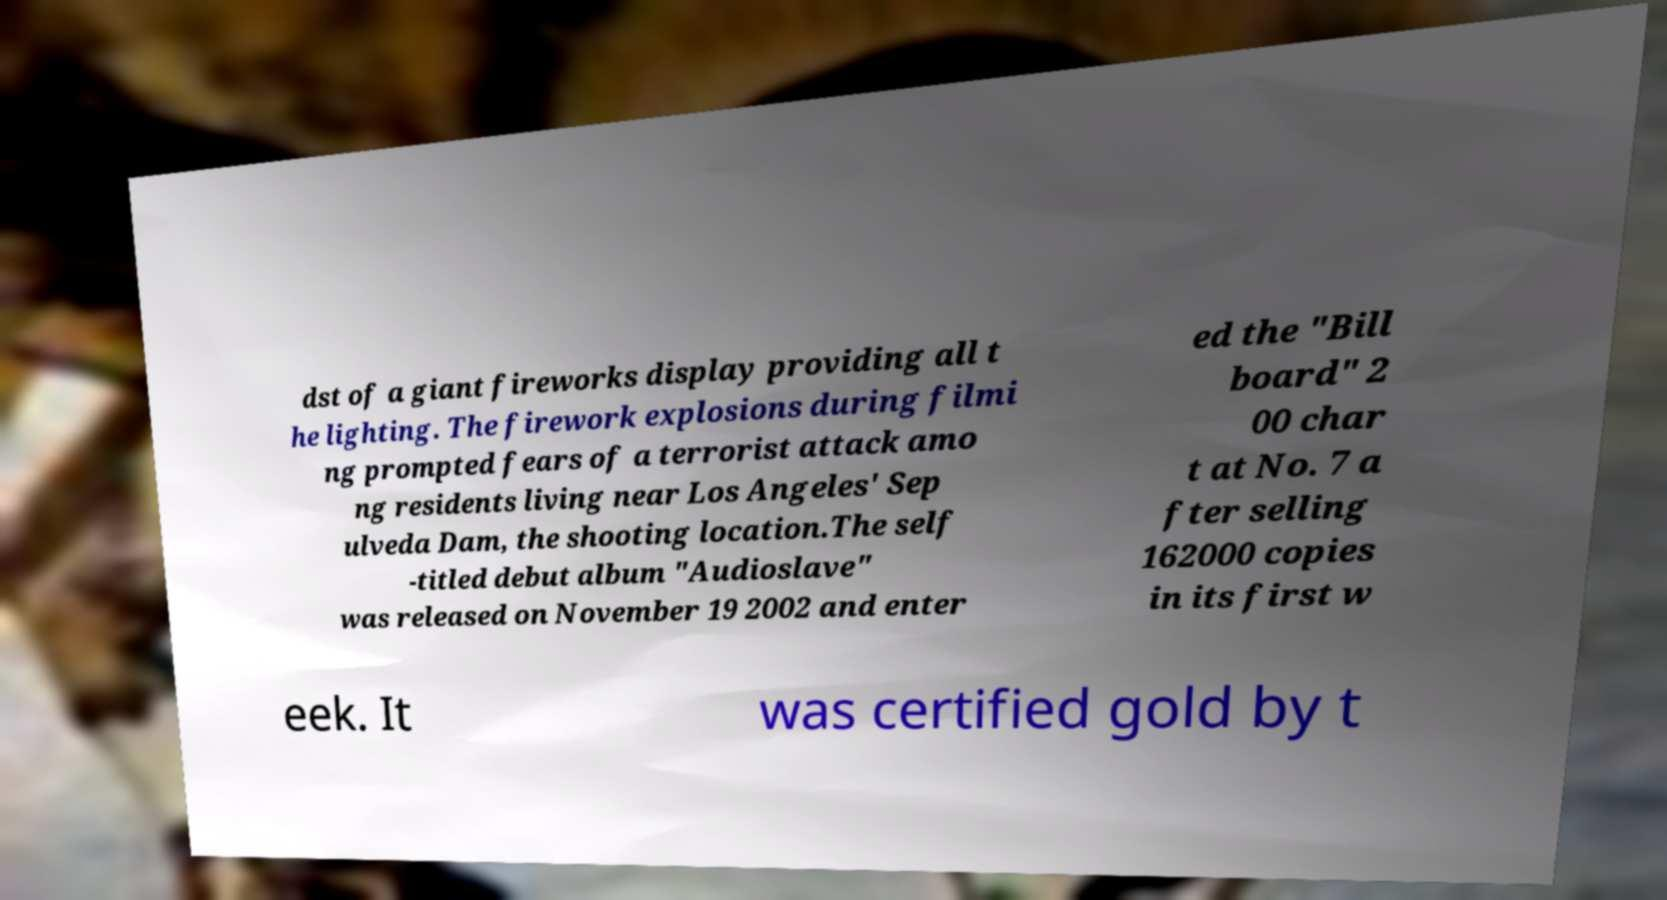Can you accurately transcribe the text from the provided image for me? dst of a giant fireworks display providing all t he lighting. The firework explosions during filmi ng prompted fears of a terrorist attack amo ng residents living near Los Angeles' Sep ulveda Dam, the shooting location.The self -titled debut album "Audioslave" was released on November 19 2002 and enter ed the "Bill board" 2 00 char t at No. 7 a fter selling 162000 copies in its first w eek. It was certified gold by t 